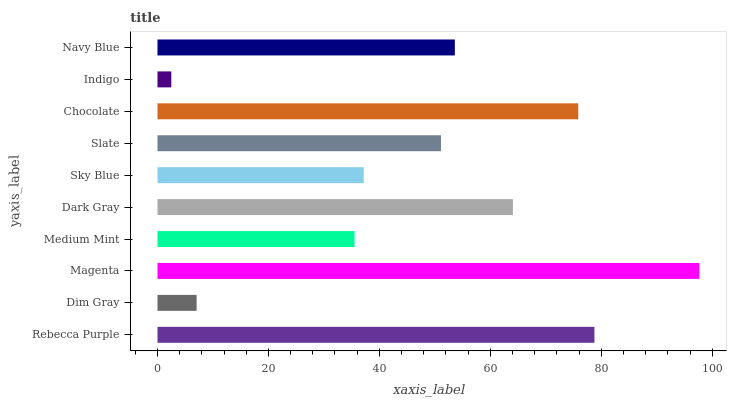Is Indigo the minimum?
Answer yes or no. Yes. Is Magenta the maximum?
Answer yes or no. Yes. Is Dim Gray the minimum?
Answer yes or no. No. Is Dim Gray the maximum?
Answer yes or no. No. Is Rebecca Purple greater than Dim Gray?
Answer yes or no. Yes. Is Dim Gray less than Rebecca Purple?
Answer yes or no. Yes. Is Dim Gray greater than Rebecca Purple?
Answer yes or no. No. Is Rebecca Purple less than Dim Gray?
Answer yes or no. No. Is Navy Blue the high median?
Answer yes or no. Yes. Is Slate the low median?
Answer yes or no. Yes. Is Medium Mint the high median?
Answer yes or no. No. Is Indigo the low median?
Answer yes or no. No. 